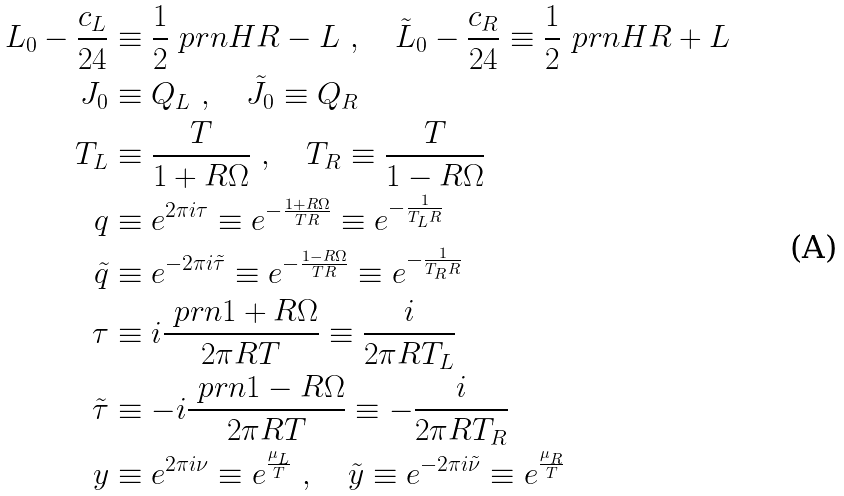<formula> <loc_0><loc_0><loc_500><loc_500>L _ { 0 } - \frac { c _ { L } } { 2 4 } & \equiv \frac { 1 } { 2 } \ p r n { H R - L } \ , \quad \tilde { L } _ { 0 } - \frac { c _ { R } } { 2 4 } \equiv \frac { 1 } { 2 } \ p r n { H R + L } \\ J _ { 0 } & \equiv Q _ { L } \ , \quad \tilde { J } _ { 0 } \equiv Q _ { R } \\ T _ { L } & \equiv \frac { T } { 1 + R \Omega } \ , \quad T _ { R } \equiv \frac { T } { 1 - R \Omega } \\ q & \equiv e ^ { 2 \pi i \tau } \equiv e ^ { - \frac { 1 + R \Omega } { T R } } \equiv e ^ { - \frac { 1 } { T _ { L } R } } \\ \tilde { q } & \equiv e ^ { - 2 \pi i \tilde { \tau } } \equiv e ^ { - \frac { 1 - R \Omega } { T R } } \equiv e ^ { - \frac { 1 } { T _ { R } R } } \\ \tau & \equiv i \frac { \ p r n { 1 + R \Omega } } { 2 \pi R T } \equiv \frac { i } { 2 \pi R T _ { L } } \\ \tilde { \tau } & \equiv - i \frac { \ p r n { 1 - R \Omega } } { 2 \pi R T } \equiv - \frac { i } { 2 \pi R T _ { R } } \\ y & \equiv e ^ { 2 \pi i \nu } \equiv e ^ { \frac { \mu _ { L } } { T } } \ , \quad \tilde { y } \equiv e ^ { - 2 \pi i \tilde { \nu } } \equiv e ^ { \frac { \mu _ { R } } { T } } \\</formula> 